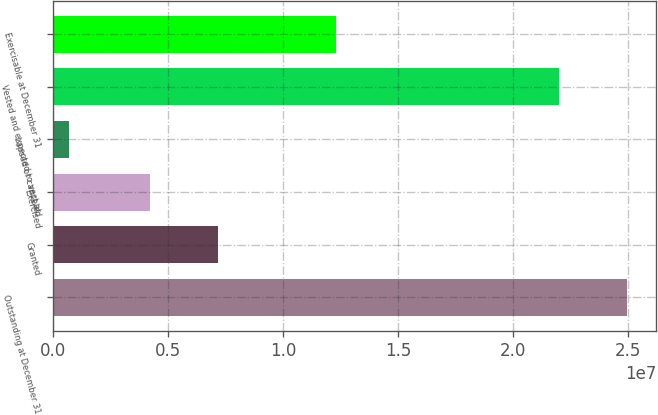Convert chart. <chart><loc_0><loc_0><loc_500><loc_500><bar_chart><fcel>Outstanding at December 31<fcel>Granted<fcel>Exercised<fcel>Lapsed or canceled<fcel>Vested and expected to vest at<fcel>Exercisable at December 31<nl><fcel>2.49661e+07<fcel>7.17693e+06<fcel>4.1903e+06<fcel>703132<fcel>2.19795e+07<fcel>1.22889e+07<nl></chart> 